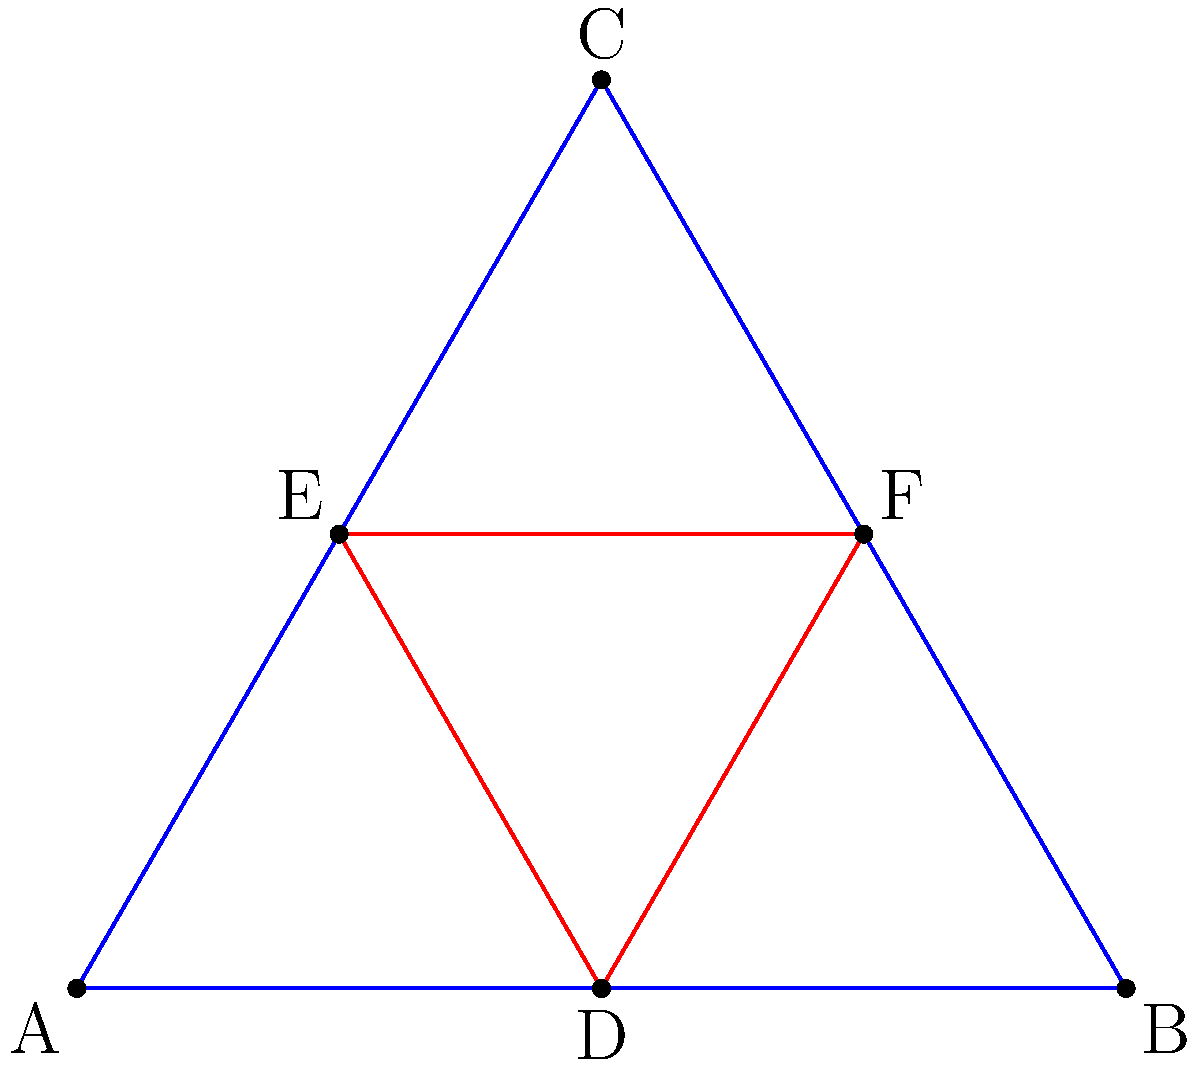In the context of molecular symmetry, consider the geometric representation above. Triangle ABC represents a planar molecule, while triangle DEF represents a different conformation of the same molecule. Which symmetry operation would transform triangle ABC into triangle DEF, and how might this relate to the molecule's potential impact on mental health receptors? To answer this question, let's analyze the symmetry operation step-by-step:

1. Observe that triangle DEF is smaller than triangle ABC and located within it.

2. The vertices of triangle DEF are:
   D: midpoint of AB
   E: located 1/3 of the way from A to C
   F: located 1/3 of the way from B to C

3. This transformation is a uniform scaling (reduction) with a scale factor of 1/2, combined with a translation.

4. In molecular terms, this operation is analogous to a conformational change where the molecule contracts while maintaining its overall shape.

5. The symmetry operation can be described as a homothety (or homothetic transformation) with scale factor 1/2 and center at the centroid of triangle ABC.

6. In the context of mental health and infectious diseases:
   - This conformational change could represent a molecule's response to environmental factors or binding to a receptor.
   - The smaller conformation (DEF) might fit better into certain neuroreceptors, potentially affecting neurotransmitter binding or synaptic function.
   - Such conformational changes could be relevant in studying how infectious agents or their byproducts interact with neural pathways, potentially influencing mental health outcomes.

7. Understanding these symmetry operations and conformational changes is crucial for designing drugs that can effectively target specific receptors or block the action of harmful molecules produced by infectious agents.
Answer: Homothetic transformation with scale factor 1/2 